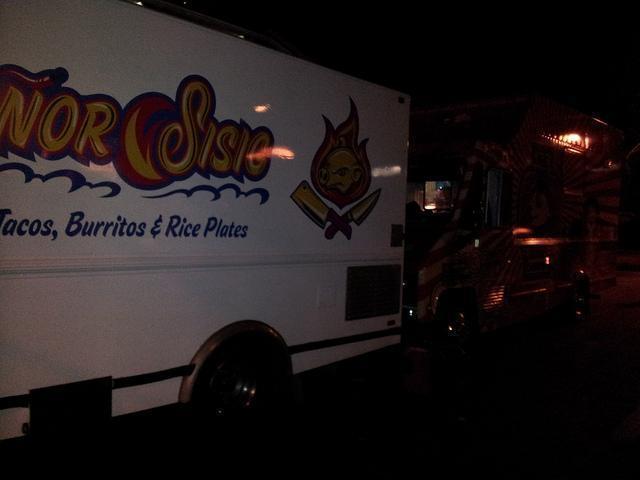What does the white truck do?
Indicate the correct response and explain using: 'Answer: answer
Rationale: rationale.'
Options: Sells food, transports passengers, transports utensils, transports rice. Answer: sells food.
Rationale: You can tell because the side of the vehicle says burritos and rice plates. 